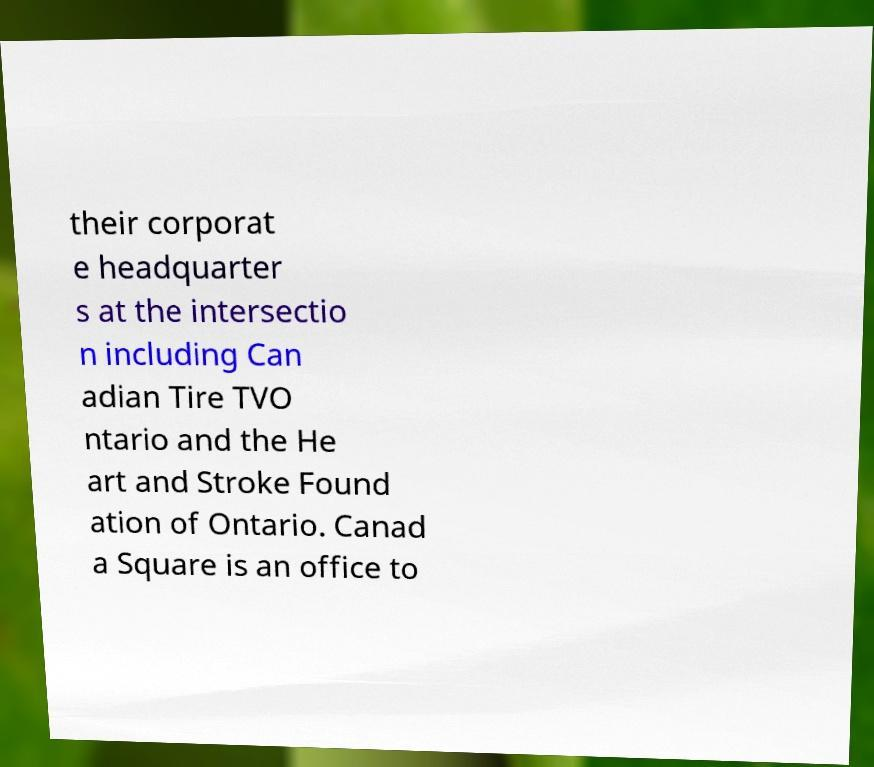For documentation purposes, I need the text within this image transcribed. Could you provide that? their corporat e headquarter s at the intersectio n including Can adian Tire TVO ntario and the He art and Stroke Found ation of Ontario. Canad a Square is an office to 